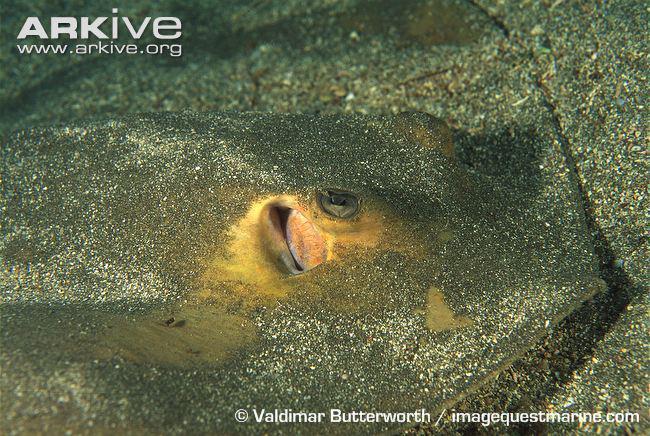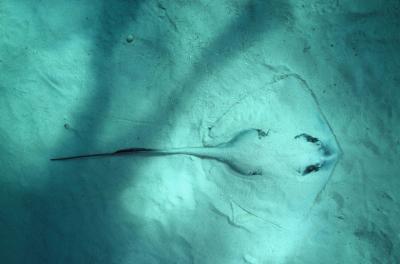The first image is the image on the left, the second image is the image on the right. Evaluate the accuracy of this statement regarding the images: "The left and right image contains the same number of  stingrays pointed the same direction.". Is it true? Answer yes or no. Yes. The first image is the image on the left, the second image is the image on the right. Analyze the images presented: Is the assertion "The stingray in the left image is nearly covered in sand." valid? Answer yes or no. Yes. 